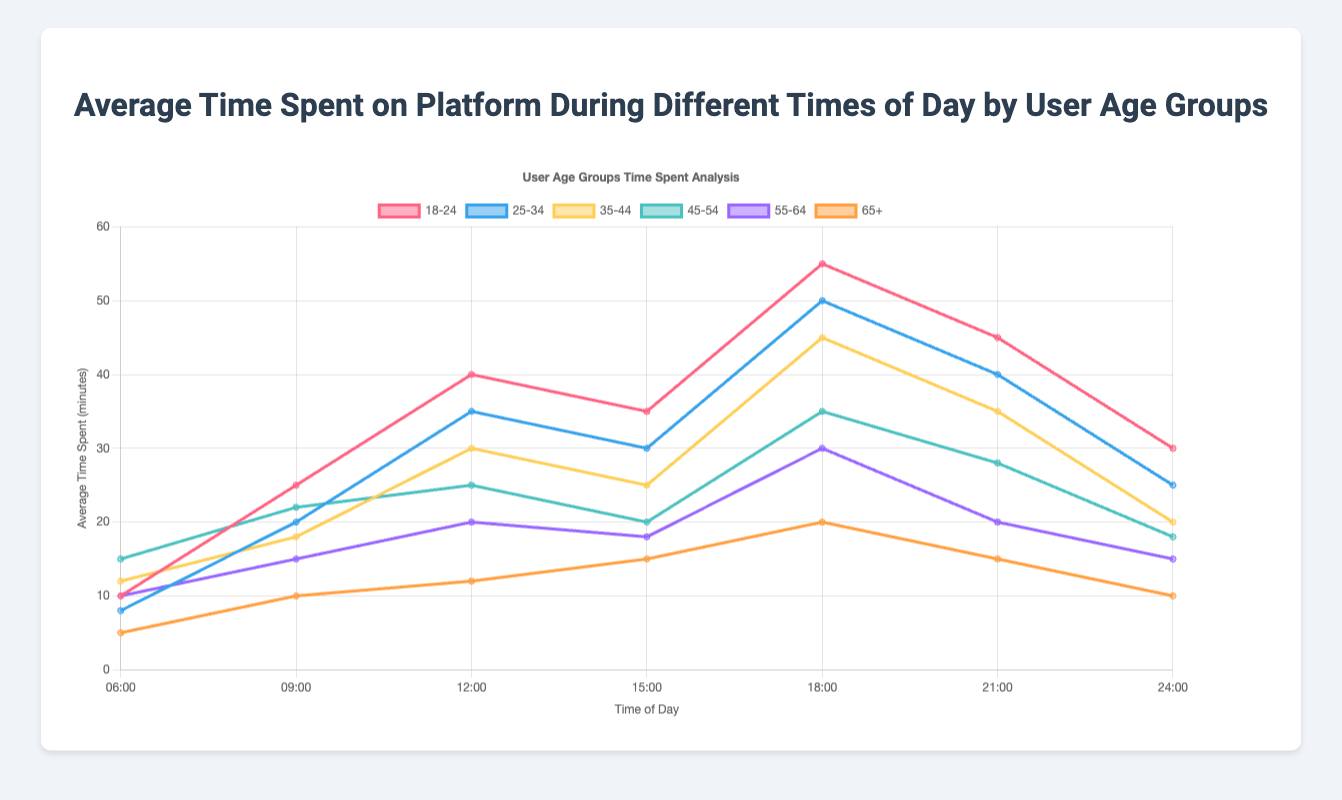Which age group spends the most time on the platform at 18:00? At 18:00, look at the highest point on the y-axis among all age groups. The 18-24 age group spends 55 minutes, which is the highest.
Answer: 18-24 What is the difference in time spent between the 18-24 and 65+ age groups at 12:00? At 12:00, find the y-values for both age groups: 18-24 age group spends 40 minutes while the 65+ age group spends 12 minutes. Subtract 12 from 40 to get the difference.
Answer: 28 minutes During which time of day do all age groups show a decline in average time spent on the platform? Examine each time point and check if the average time spent subsequently declines from that point. At 21:00, the average time decreases for every age group by 24:00.
Answer: 21:00 to 24:00 Which age group shows the least variation in average time spent on the platform throughout the day? Compare the range of data points for each age group (max - min). The 65+ age group shows the least variation, with a range of 20 - 5 = 15 minutes.
Answer: 65+ What is the sum of the average time spent at 18:00 across all age groups? Add the average times spent at 18:00 for all age groups: 55 + 50 + 45 + 35 + 30 + 20 = 235 minutes.
Answer: 235 minutes What is the trend observed for the 25-34 age group between 09:00 and 18:00? Look at the line for the 25-34 age group and trace the y-values from 09:00 to 18:00. There is an increasing trend from 20 minutes at 09:00 to 50 minutes at 18:00.
Answer: Increasing How does the average time spent by the 18-24 age group at 09:00 compare with the time spent by the 35-44 age group at the same time? Look at the y-values at 09:00 for both age groups: 18-24 age group spends 25 minutes, and 35-44 age group spends 18 minutes. 25 is greater than 18.
Answer: 18-24 > 35-44 What is the average time spent on the platform at 06:00 for all age groups combined? Calculate the average of the values at 06:00: (10 + 8 + 12 + 15 + 10 + 5) / 6 = 60 / 6 = 10 minutes.
Answer: 10 minutes Which age group spends significantly more time on the platform during late evening hours (21:00-24:00) compared to early morning hours (06:00-09:00)? Compare the difference between the early morning (average of 06:00 and 09:00) and late evening (average of 21:00 and 24:00) values for each age group. The 18-24 age group has the highest increase (47.5 - 17.5 = 30).
Answer: 18-24 At what time of day is the average time spent on the platform highest for the 45-54 age group? Find the maximum y-value for the 45-54 age group and the corresponding x-value (time). The highest point is at 18:00 with 35 minutes.
Answer: 18:00 